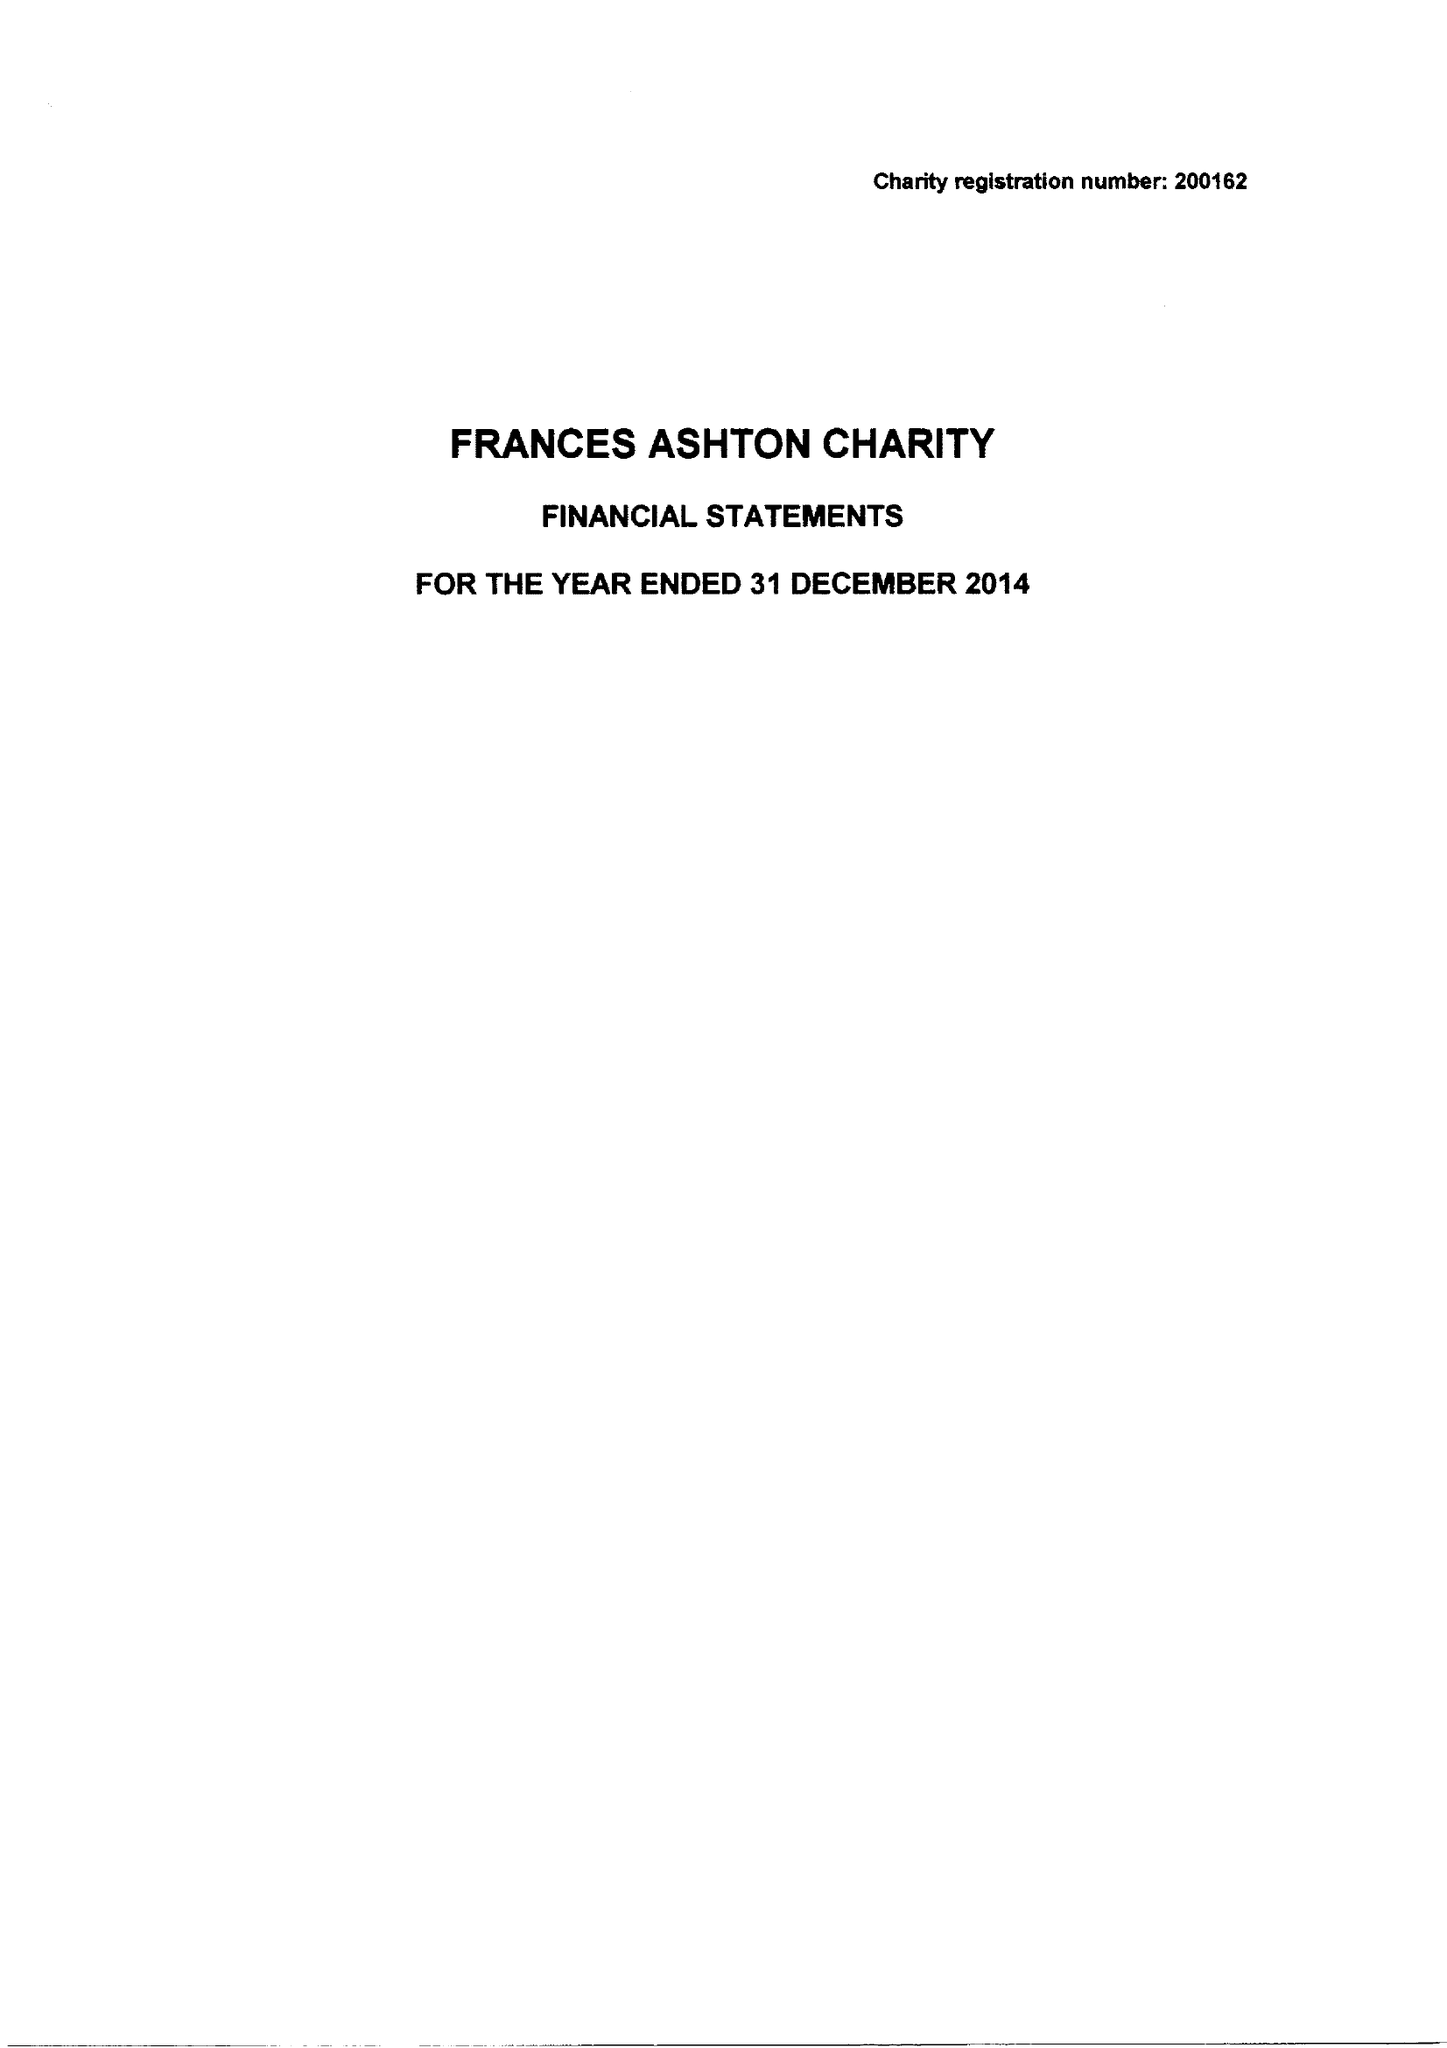What is the value for the charity_name?
Answer the question using a single word or phrase. Frances Ashton's Charity 